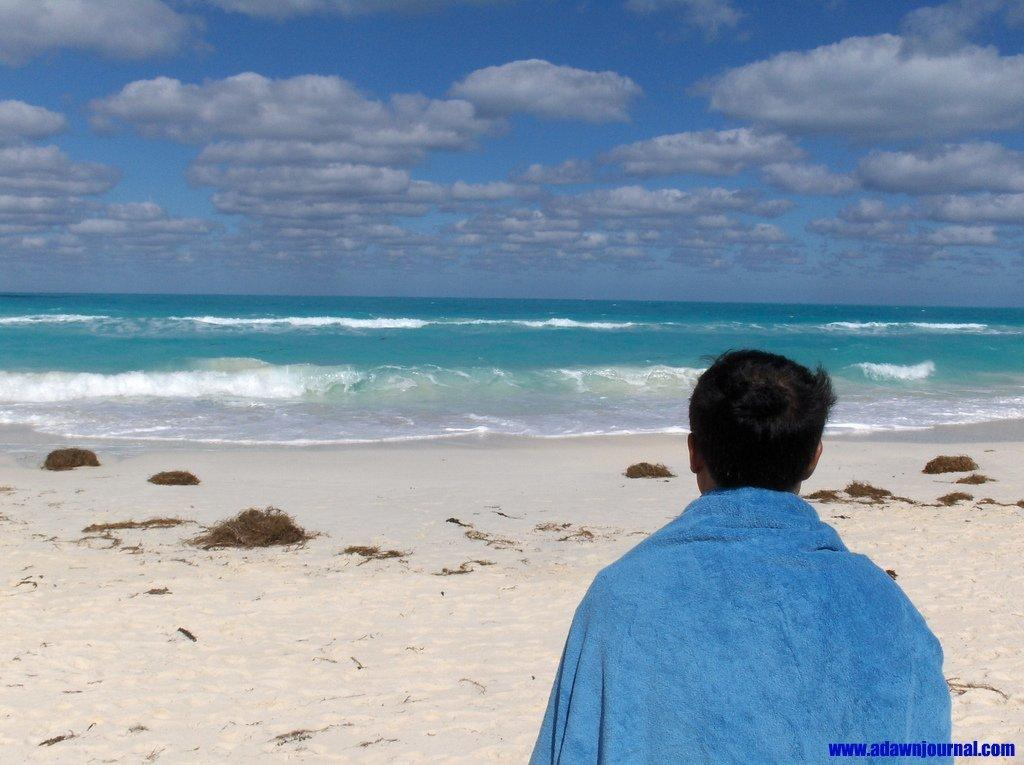Where was the image taken? The image was taken at the beach. Can you describe the main subject in the image? There is a man in the image. What natural elements can be seen in the image? There is water, sand, and the sky visible in the image. What is the condition of the sky in the image? Clouds are present in the sky. Is there any text in the image? Yes, there is text is present in the bottom right corner of the image. What type of yoke is the man using to carry the rifle in the image? There is no yoke or rifle present in the image; it is taken at the beach and features a man with no such items. 